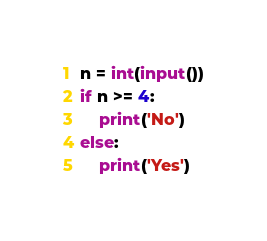Convert code to text. <code><loc_0><loc_0><loc_500><loc_500><_Python_>n = int(input())
if n >= 4:
    print('No')
else:
    print('Yes')</code> 